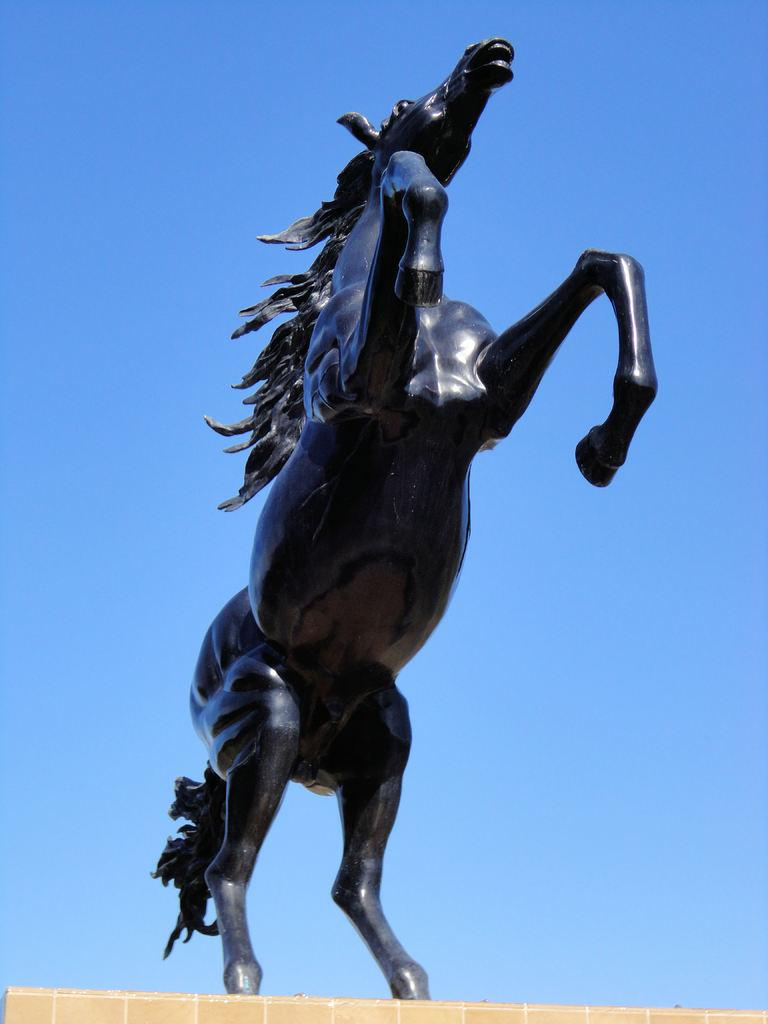What is the main subject of the image? There is a statue of an animal in the image. What color is the background of the image? The background of the image is blue. What color is present at the bottom of the image? There is yellow color at the bottom of the image. What type of punishment is being administered in the image? There is no punishment being administered in the image; it features a statue of an animal with a blue background and yellow at the bottom. Can you tell me where the church is located in the image? There is no church present in the image. 